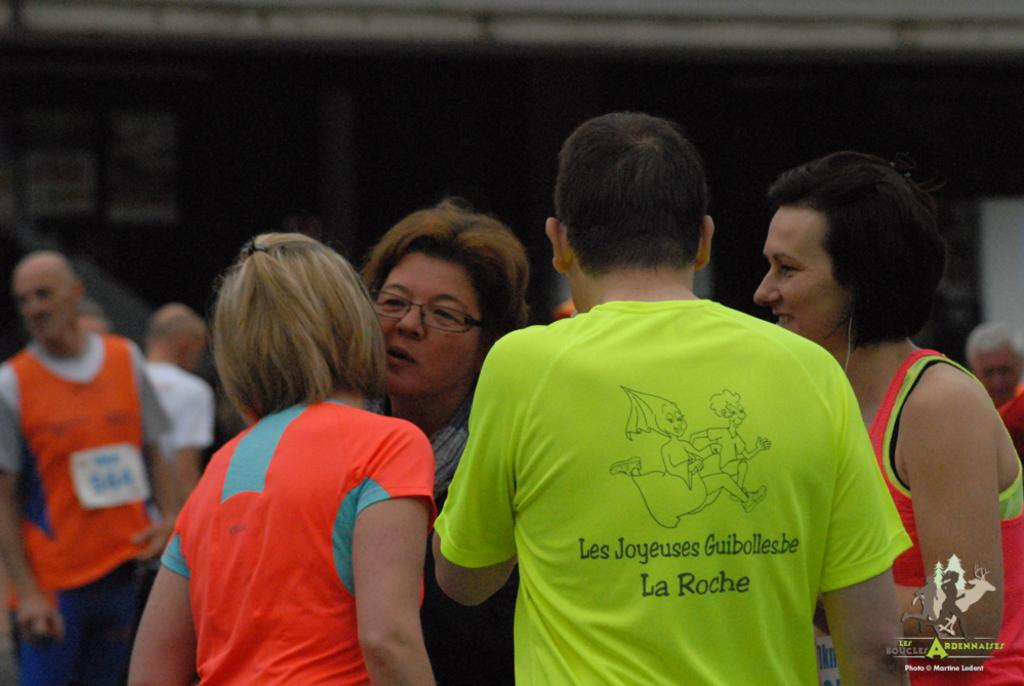What is happening in the image? There are people standing in the image. What can be seen on the right side of the image? There is a text and a log on the right side of the image. How would you describe the background of the image? The background of the image is blurred. What type of pin is being used to hold the text in the image? There is no pin present in the image; the text is simply on the right side of the image. 